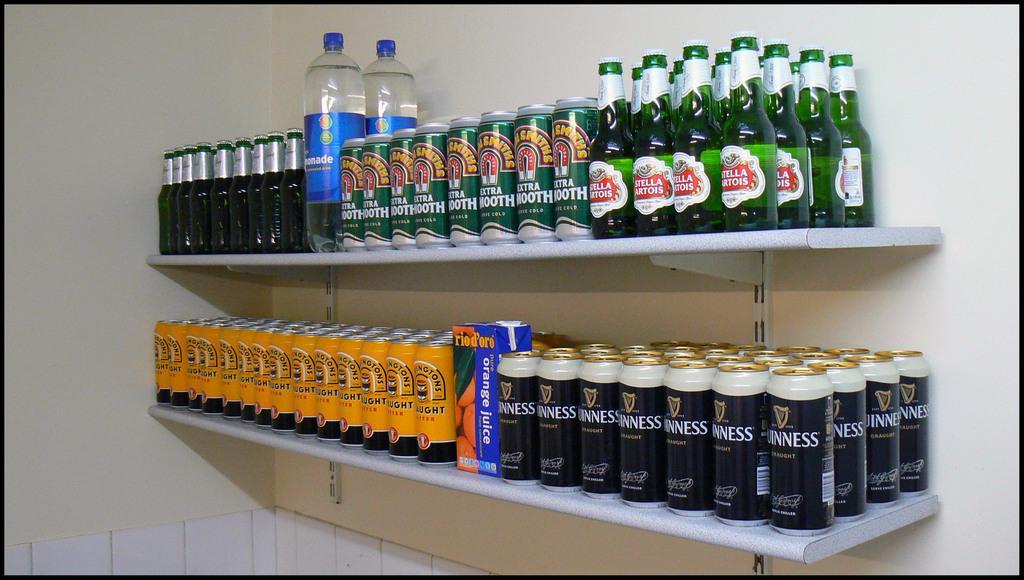In one or two sentences, can you explain what this image depicts? In this picture there is a shelf in which some tins, bottles and some water bottles were placed. In the background there is a wall. 